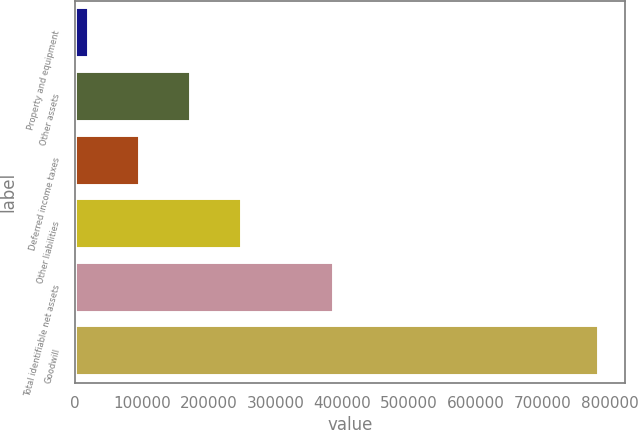Convert chart. <chart><loc_0><loc_0><loc_500><loc_500><bar_chart><fcel>Property and equipment<fcel>Other assets<fcel>Deferred income taxes<fcel>Other liabilities<fcel>Total identifiable net assets<fcel>Goodwill<nl><fcel>21852<fcel>174330<fcel>98091.2<fcel>250570<fcel>387332<fcel>784244<nl></chart> 